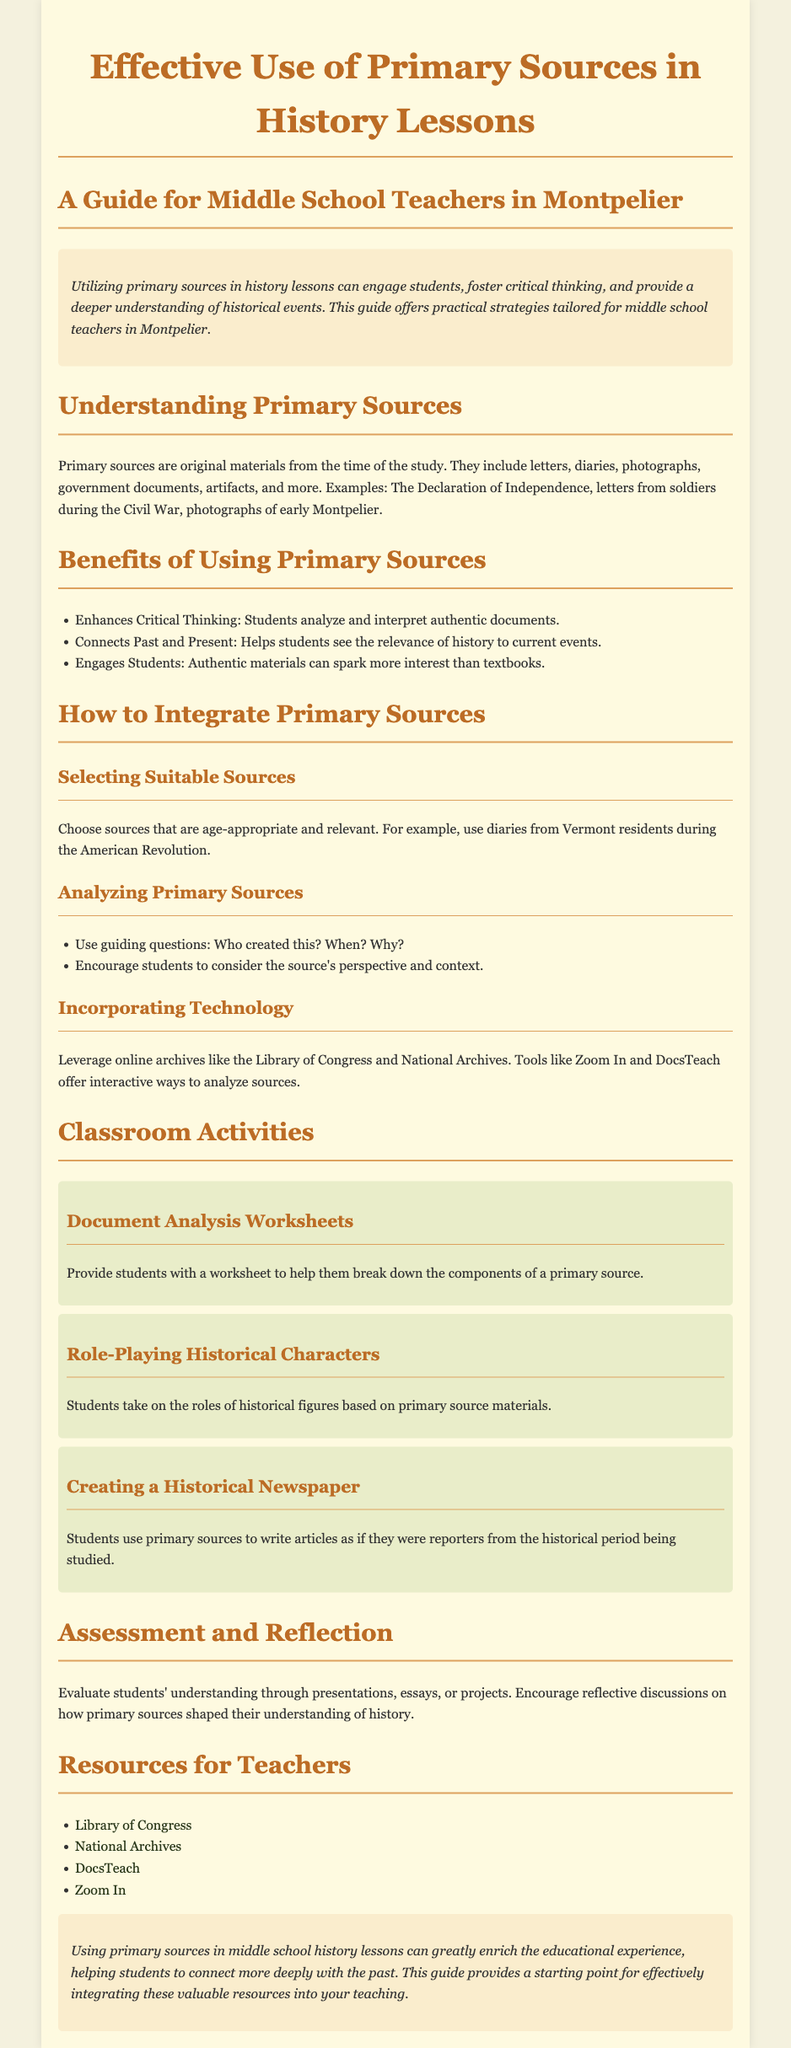What are primary sources? Primary sources are original materials from the time of the study, including letters, diaries, photographs, government documents, and artifacts.
Answer: Original materials What is one benefit of using primary sources? The guide lists multiple benefits, one of which is that they enhance critical thinking by allowing students to analyze and interpret authentic documents.
Answer: Enhances Critical Thinking What is the suggested activity involving historical characters? The guide suggests a role-playing activity where students take on the roles of historical figures based on primary source materials.
Answer: Role-Playing Historical Characters What is the URL for the Library of Congress? The resources section provides a link to the Library of Congress, which is https://www.loc.gov.
Answer: https://www.loc.gov Which specific tool is mentioned for analyzing sources? The guide mentions tools like Zoom In and DocsTeach as interactive ways to analyze sources.
Answer: Zoom In and DocsTeach What should teachers consider when selecting sources? Teachers should choose age-appropriate and relevant sources, such as diaries from Vermont residents during the American Revolution.
Answer: Age-appropriate and relevant sources How should students reflect on their understanding of history? The guide recommends encouraging reflective discussions on how primary sources shaped students' understanding of history.
Answer: Reflective discussions What is the main purpose of this guide? The primary purpose is to provide practical strategies for middle school teachers to effectively integrate primary sources into their history lessons.
Answer: Practical strategies for teachers 